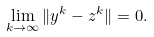<formula> <loc_0><loc_0><loc_500><loc_500>\lim _ { k \to \infty } \| y ^ { k } - z ^ { k } \| = 0 .</formula> 